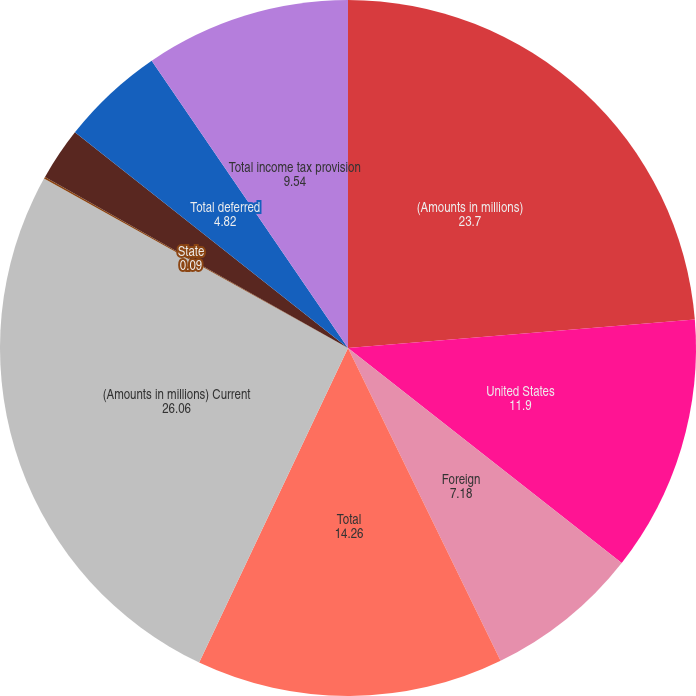Convert chart. <chart><loc_0><loc_0><loc_500><loc_500><pie_chart><fcel>(Amounts in millions)<fcel>United States<fcel>Foreign<fcel>Total<fcel>(Amounts in millions) Current<fcel>State<fcel>Deferred Federal<fcel>Total deferred<fcel>Total income tax provision<nl><fcel>23.7%<fcel>11.9%<fcel>7.18%<fcel>14.26%<fcel>26.06%<fcel>0.09%<fcel>2.46%<fcel>4.82%<fcel>9.54%<nl></chart> 